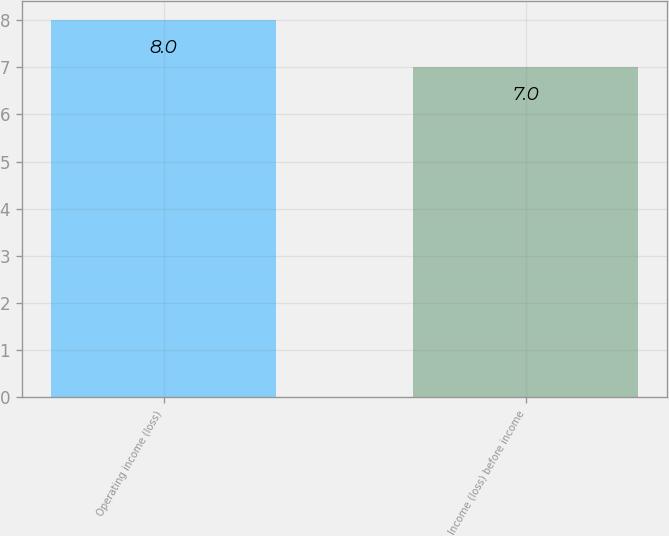<chart> <loc_0><loc_0><loc_500><loc_500><bar_chart><fcel>Operating income (loss)<fcel>Income (loss) before income<nl><fcel>8<fcel>7<nl></chart> 